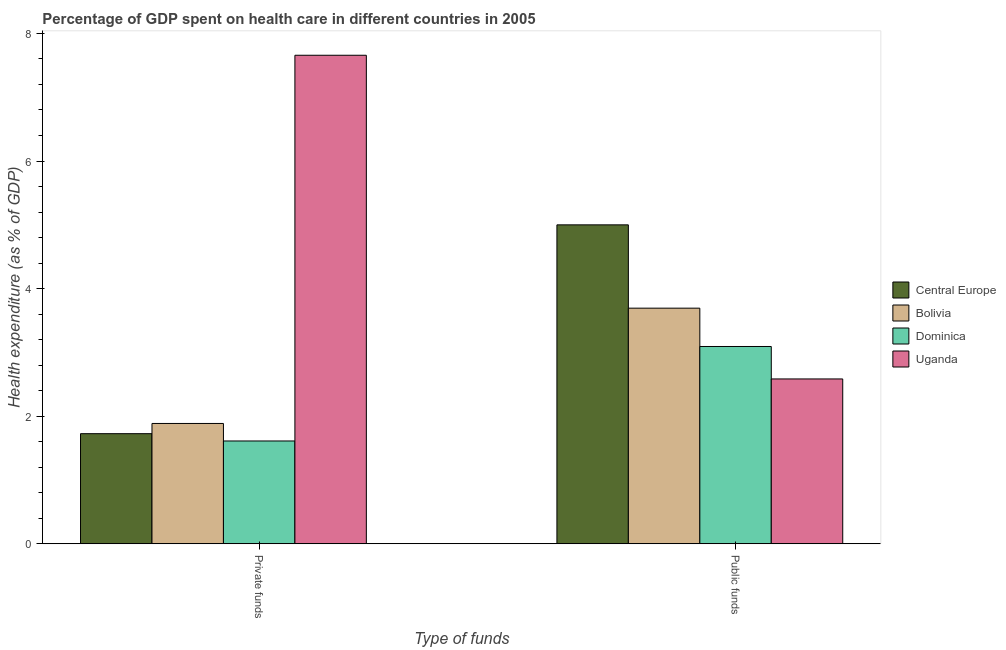Are the number of bars on each tick of the X-axis equal?
Provide a short and direct response. Yes. What is the label of the 1st group of bars from the left?
Offer a very short reply. Private funds. What is the amount of private funds spent in healthcare in Central Europe?
Offer a terse response. 1.73. Across all countries, what is the maximum amount of public funds spent in healthcare?
Ensure brevity in your answer.  5. Across all countries, what is the minimum amount of private funds spent in healthcare?
Ensure brevity in your answer.  1.61. In which country was the amount of private funds spent in healthcare maximum?
Offer a very short reply. Uganda. In which country was the amount of public funds spent in healthcare minimum?
Keep it short and to the point. Uganda. What is the total amount of private funds spent in healthcare in the graph?
Your answer should be very brief. 12.88. What is the difference between the amount of public funds spent in healthcare in Bolivia and that in Uganda?
Give a very brief answer. 1.11. What is the difference between the amount of private funds spent in healthcare in Bolivia and the amount of public funds spent in healthcare in Uganda?
Offer a terse response. -0.7. What is the average amount of private funds spent in healthcare per country?
Give a very brief answer. 3.22. What is the difference between the amount of public funds spent in healthcare and amount of private funds spent in healthcare in Uganda?
Provide a short and direct response. -5.07. What is the ratio of the amount of private funds spent in healthcare in Uganda to that in Dominica?
Offer a very short reply. 4.75. Is the amount of private funds spent in healthcare in Bolivia less than that in Uganda?
Provide a succinct answer. Yes. In how many countries, is the amount of private funds spent in healthcare greater than the average amount of private funds spent in healthcare taken over all countries?
Your answer should be very brief. 1. What does the 3rd bar from the left in Private funds represents?
Your answer should be compact. Dominica. What does the 2nd bar from the right in Public funds represents?
Your response must be concise. Dominica. How many legend labels are there?
Make the answer very short. 4. How are the legend labels stacked?
Make the answer very short. Vertical. What is the title of the graph?
Provide a short and direct response. Percentage of GDP spent on health care in different countries in 2005. Does "Mauritania" appear as one of the legend labels in the graph?
Your answer should be compact. No. What is the label or title of the X-axis?
Make the answer very short. Type of funds. What is the label or title of the Y-axis?
Offer a terse response. Health expenditure (as % of GDP). What is the Health expenditure (as % of GDP) of Central Europe in Private funds?
Give a very brief answer. 1.73. What is the Health expenditure (as % of GDP) in Bolivia in Private funds?
Your answer should be very brief. 1.89. What is the Health expenditure (as % of GDP) in Dominica in Private funds?
Provide a short and direct response. 1.61. What is the Health expenditure (as % of GDP) of Uganda in Private funds?
Your answer should be very brief. 7.66. What is the Health expenditure (as % of GDP) in Central Europe in Public funds?
Provide a succinct answer. 5. What is the Health expenditure (as % of GDP) of Bolivia in Public funds?
Provide a succinct answer. 3.69. What is the Health expenditure (as % of GDP) in Dominica in Public funds?
Offer a terse response. 3.09. What is the Health expenditure (as % of GDP) in Uganda in Public funds?
Provide a succinct answer. 2.58. Across all Type of funds, what is the maximum Health expenditure (as % of GDP) of Central Europe?
Make the answer very short. 5. Across all Type of funds, what is the maximum Health expenditure (as % of GDP) in Bolivia?
Provide a short and direct response. 3.69. Across all Type of funds, what is the maximum Health expenditure (as % of GDP) in Dominica?
Ensure brevity in your answer.  3.09. Across all Type of funds, what is the maximum Health expenditure (as % of GDP) of Uganda?
Make the answer very short. 7.66. Across all Type of funds, what is the minimum Health expenditure (as % of GDP) of Central Europe?
Give a very brief answer. 1.73. Across all Type of funds, what is the minimum Health expenditure (as % of GDP) of Bolivia?
Provide a short and direct response. 1.89. Across all Type of funds, what is the minimum Health expenditure (as % of GDP) in Dominica?
Provide a succinct answer. 1.61. Across all Type of funds, what is the minimum Health expenditure (as % of GDP) of Uganda?
Provide a succinct answer. 2.58. What is the total Health expenditure (as % of GDP) in Central Europe in the graph?
Your response must be concise. 6.73. What is the total Health expenditure (as % of GDP) in Bolivia in the graph?
Provide a short and direct response. 5.58. What is the total Health expenditure (as % of GDP) of Dominica in the graph?
Provide a short and direct response. 4.7. What is the total Health expenditure (as % of GDP) of Uganda in the graph?
Give a very brief answer. 10.24. What is the difference between the Health expenditure (as % of GDP) of Central Europe in Private funds and that in Public funds?
Offer a terse response. -3.27. What is the difference between the Health expenditure (as % of GDP) of Bolivia in Private funds and that in Public funds?
Provide a short and direct response. -1.81. What is the difference between the Health expenditure (as % of GDP) in Dominica in Private funds and that in Public funds?
Give a very brief answer. -1.48. What is the difference between the Health expenditure (as % of GDP) of Uganda in Private funds and that in Public funds?
Offer a very short reply. 5.07. What is the difference between the Health expenditure (as % of GDP) of Central Europe in Private funds and the Health expenditure (as % of GDP) of Bolivia in Public funds?
Provide a succinct answer. -1.97. What is the difference between the Health expenditure (as % of GDP) of Central Europe in Private funds and the Health expenditure (as % of GDP) of Dominica in Public funds?
Offer a very short reply. -1.37. What is the difference between the Health expenditure (as % of GDP) of Central Europe in Private funds and the Health expenditure (as % of GDP) of Uganda in Public funds?
Keep it short and to the point. -0.86. What is the difference between the Health expenditure (as % of GDP) in Bolivia in Private funds and the Health expenditure (as % of GDP) in Dominica in Public funds?
Provide a succinct answer. -1.21. What is the difference between the Health expenditure (as % of GDP) in Bolivia in Private funds and the Health expenditure (as % of GDP) in Uganda in Public funds?
Keep it short and to the point. -0.7. What is the difference between the Health expenditure (as % of GDP) of Dominica in Private funds and the Health expenditure (as % of GDP) of Uganda in Public funds?
Give a very brief answer. -0.97. What is the average Health expenditure (as % of GDP) in Central Europe per Type of funds?
Your response must be concise. 3.36. What is the average Health expenditure (as % of GDP) of Bolivia per Type of funds?
Provide a succinct answer. 2.79. What is the average Health expenditure (as % of GDP) in Dominica per Type of funds?
Make the answer very short. 2.35. What is the average Health expenditure (as % of GDP) in Uganda per Type of funds?
Offer a terse response. 5.12. What is the difference between the Health expenditure (as % of GDP) in Central Europe and Health expenditure (as % of GDP) in Bolivia in Private funds?
Provide a succinct answer. -0.16. What is the difference between the Health expenditure (as % of GDP) in Central Europe and Health expenditure (as % of GDP) in Dominica in Private funds?
Your answer should be compact. 0.11. What is the difference between the Health expenditure (as % of GDP) of Central Europe and Health expenditure (as % of GDP) of Uganda in Private funds?
Provide a succinct answer. -5.93. What is the difference between the Health expenditure (as % of GDP) in Bolivia and Health expenditure (as % of GDP) in Dominica in Private funds?
Offer a terse response. 0.27. What is the difference between the Health expenditure (as % of GDP) of Bolivia and Health expenditure (as % of GDP) of Uganda in Private funds?
Your answer should be very brief. -5.77. What is the difference between the Health expenditure (as % of GDP) of Dominica and Health expenditure (as % of GDP) of Uganda in Private funds?
Provide a succinct answer. -6.05. What is the difference between the Health expenditure (as % of GDP) in Central Europe and Health expenditure (as % of GDP) in Bolivia in Public funds?
Provide a succinct answer. 1.31. What is the difference between the Health expenditure (as % of GDP) of Central Europe and Health expenditure (as % of GDP) of Dominica in Public funds?
Keep it short and to the point. 1.91. What is the difference between the Health expenditure (as % of GDP) of Central Europe and Health expenditure (as % of GDP) of Uganda in Public funds?
Your response must be concise. 2.42. What is the difference between the Health expenditure (as % of GDP) in Bolivia and Health expenditure (as % of GDP) in Dominica in Public funds?
Your response must be concise. 0.6. What is the difference between the Health expenditure (as % of GDP) of Bolivia and Health expenditure (as % of GDP) of Uganda in Public funds?
Make the answer very short. 1.11. What is the difference between the Health expenditure (as % of GDP) of Dominica and Health expenditure (as % of GDP) of Uganda in Public funds?
Provide a succinct answer. 0.51. What is the ratio of the Health expenditure (as % of GDP) of Central Europe in Private funds to that in Public funds?
Offer a very short reply. 0.35. What is the ratio of the Health expenditure (as % of GDP) of Bolivia in Private funds to that in Public funds?
Offer a terse response. 0.51. What is the ratio of the Health expenditure (as % of GDP) of Dominica in Private funds to that in Public funds?
Make the answer very short. 0.52. What is the ratio of the Health expenditure (as % of GDP) in Uganda in Private funds to that in Public funds?
Make the answer very short. 2.96. What is the difference between the highest and the second highest Health expenditure (as % of GDP) in Central Europe?
Offer a terse response. 3.27. What is the difference between the highest and the second highest Health expenditure (as % of GDP) in Bolivia?
Your answer should be compact. 1.81. What is the difference between the highest and the second highest Health expenditure (as % of GDP) in Dominica?
Your response must be concise. 1.48. What is the difference between the highest and the second highest Health expenditure (as % of GDP) of Uganda?
Provide a succinct answer. 5.07. What is the difference between the highest and the lowest Health expenditure (as % of GDP) in Central Europe?
Offer a very short reply. 3.27. What is the difference between the highest and the lowest Health expenditure (as % of GDP) in Bolivia?
Offer a terse response. 1.81. What is the difference between the highest and the lowest Health expenditure (as % of GDP) of Dominica?
Provide a short and direct response. 1.48. What is the difference between the highest and the lowest Health expenditure (as % of GDP) of Uganda?
Give a very brief answer. 5.07. 